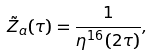Convert formula to latex. <formula><loc_0><loc_0><loc_500><loc_500>\tilde { Z } _ { a } ( \tau ) = \frac { 1 } { \eta ^ { 1 6 } ( 2 \tau ) } ,</formula> 